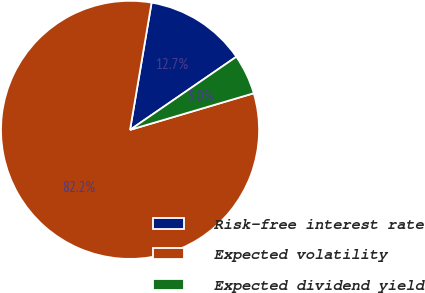Convert chart to OTSL. <chart><loc_0><loc_0><loc_500><loc_500><pie_chart><fcel>Risk-free interest rate<fcel>Expected volatility<fcel>Expected dividend yield<nl><fcel>12.74%<fcel>82.25%<fcel>5.01%<nl></chart> 